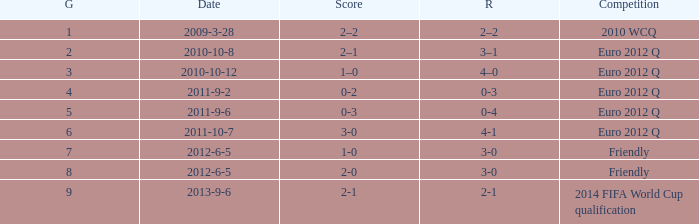How many goals when the score is 3-0 in the euro 2012 q? 1.0. 